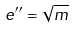<formula> <loc_0><loc_0><loc_500><loc_500>e ^ { \prime \prime } = \sqrt { m }</formula> 